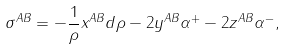<formula> <loc_0><loc_0><loc_500><loc_500>\sigma ^ { A B } = - \frac { 1 } { \rho } x ^ { A B } d \rho - 2 y ^ { A B } \alpha ^ { + } - 2 z ^ { A B } \alpha ^ { - } ,</formula> 